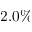Convert formula to latex. <formula><loc_0><loc_0><loc_500><loc_500>2 . 0 \%</formula> 